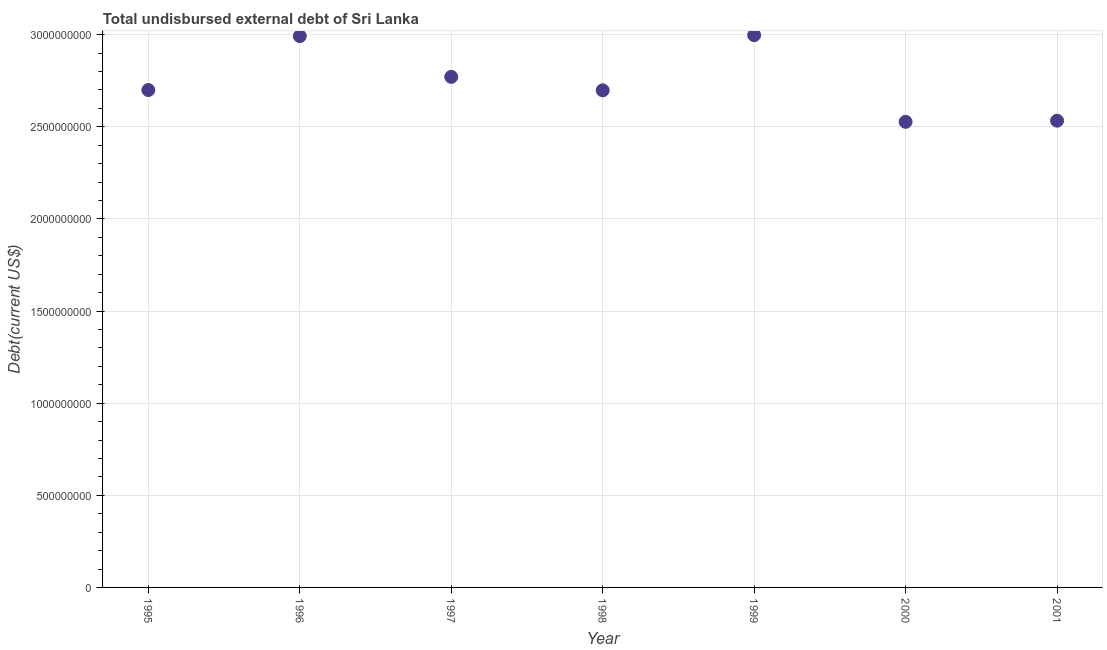What is the total debt in 1995?
Provide a succinct answer. 2.70e+09. Across all years, what is the maximum total debt?
Offer a very short reply. 3.00e+09. Across all years, what is the minimum total debt?
Keep it short and to the point. 2.53e+09. In which year was the total debt maximum?
Your answer should be very brief. 1999. In which year was the total debt minimum?
Provide a succinct answer. 2000. What is the sum of the total debt?
Ensure brevity in your answer.  1.92e+1. What is the difference between the total debt in 1995 and 1997?
Your response must be concise. -7.15e+07. What is the average total debt per year?
Provide a succinct answer. 2.75e+09. What is the median total debt?
Offer a terse response. 2.70e+09. In how many years, is the total debt greater than 2000000000 US$?
Offer a terse response. 7. Do a majority of the years between 1996 and 2001 (inclusive) have total debt greater than 1200000000 US$?
Provide a succinct answer. Yes. What is the ratio of the total debt in 1995 to that in 1996?
Your response must be concise. 0.9. Is the difference between the total debt in 1997 and 1999 greater than the difference between any two years?
Give a very brief answer. No. What is the difference between the highest and the second highest total debt?
Ensure brevity in your answer.  5.28e+06. Is the sum of the total debt in 1995 and 2001 greater than the maximum total debt across all years?
Your response must be concise. Yes. What is the difference between the highest and the lowest total debt?
Offer a very short reply. 4.70e+08. In how many years, is the total debt greater than the average total debt taken over all years?
Give a very brief answer. 3. What is the difference between two consecutive major ticks on the Y-axis?
Your response must be concise. 5.00e+08. Does the graph contain grids?
Provide a short and direct response. Yes. What is the title of the graph?
Offer a terse response. Total undisbursed external debt of Sri Lanka. What is the label or title of the Y-axis?
Give a very brief answer. Debt(current US$). What is the Debt(current US$) in 1995?
Provide a succinct answer. 2.70e+09. What is the Debt(current US$) in 1996?
Give a very brief answer. 2.99e+09. What is the Debt(current US$) in 1997?
Provide a short and direct response. 2.77e+09. What is the Debt(current US$) in 1998?
Your answer should be compact. 2.70e+09. What is the Debt(current US$) in 1999?
Your answer should be very brief. 3.00e+09. What is the Debt(current US$) in 2000?
Keep it short and to the point. 2.53e+09. What is the Debt(current US$) in 2001?
Offer a very short reply. 2.53e+09. What is the difference between the Debt(current US$) in 1995 and 1996?
Make the answer very short. -2.93e+08. What is the difference between the Debt(current US$) in 1995 and 1997?
Keep it short and to the point. -7.15e+07. What is the difference between the Debt(current US$) in 1995 and 1998?
Ensure brevity in your answer.  1.53e+06. What is the difference between the Debt(current US$) in 1995 and 1999?
Give a very brief answer. -2.98e+08. What is the difference between the Debt(current US$) in 1995 and 2000?
Keep it short and to the point. 1.72e+08. What is the difference between the Debt(current US$) in 1995 and 2001?
Keep it short and to the point. 1.66e+08. What is the difference between the Debt(current US$) in 1996 and 1997?
Give a very brief answer. 2.21e+08. What is the difference between the Debt(current US$) in 1996 and 1998?
Offer a terse response. 2.94e+08. What is the difference between the Debt(current US$) in 1996 and 1999?
Offer a very short reply. -5.28e+06. What is the difference between the Debt(current US$) in 1996 and 2000?
Your answer should be compact. 4.65e+08. What is the difference between the Debt(current US$) in 1996 and 2001?
Your answer should be very brief. 4.59e+08. What is the difference between the Debt(current US$) in 1997 and 1998?
Provide a short and direct response. 7.30e+07. What is the difference between the Debt(current US$) in 1997 and 1999?
Provide a succinct answer. -2.26e+08. What is the difference between the Debt(current US$) in 1997 and 2000?
Your response must be concise. 2.44e+08. What is the difference between the Debt(current US$) in 1997 and 2001?
Your answer should be very brief. 2.38e+08. What is the difference between the Debt(current US$) in 1998 and 1999?
Your answer should be compact. -2.99e+08. What is the difference between the Debt(current US$) in 1998 and 2000?
Your response must be concise. 1.71e+08. What is the difference between the Debt(current US$) in 1998 and 2001?
Provide a short and direct response. 1.65e+08. What is the difference between the Debt(current US$) in 1999 and 2000?
Give a very brief answer. 4.70e+08. What is the difference between the Debt(current US$) in 1999 and 2001?
Your answer should be very brief. 4.64e+08. What is the difference between the Debt(current US$) in 2000 and 2001?
Give a very brief answer. -6.21e+06. What is the ratio of the Debt(current US$) in 1995 to that in 1996?
Your answer should be compact. 0.9. What is the ratio of the Debt(current US$) in 1995 to that in 1997?
Keep it short and to the point. 0.97. What is the ratio of the Debt(current US$) in 1995 to that in 1999?
Ensure brevity in your answer.  0.9. What is the ratio of the Debt(current US$) in 1995 to that in 2000?
Ensure brevity in your answer.  1.07. What is the ratio of the Debt(current US$) in 1995 to that in 2001?
Keep it short and to the point. 1.07. What is the ratio of the Debt(current US$) in 1996 to that in 1997?
Your response must be concise. 1.08. What is the ratio of the Debt(current US$) in 1996 to that in 1998?
Provide a short and direct response. 1.11. What is the ratio of the Debt(current US$) in 1996 to that in 2000?
Ensure brevity in your answer.  1.18. What is the ratio of the Debt(current US$) in 1996 to that in 2001?
Give a very brief answer. 1.18. What is the ratio of the Debt(current US$) in 1997 to that in 1999?
Ensure brevity in your answer.  0.92. What is the ratio of the Debt(current US$) in 1997 to that in 2000?
Give a very brief answer. 1.1. What is the ratio of the Debt(current US$) in 1997 to that in 2001?
Offer a terse response. 1.09. What is the ratio of the Debt(current US$) in 1998 to that in 1999?
Ensure brevity in your answer.  0.9. What is the ratio of the Debt(current US$) in 1998 to that in 2000?
Ensure brevity in your answer.  1.07. What is the ratio of the Debt(current US$) in 1998 to that in 2001?
Provide a short and direct response. 1.06. What is the ratio of the Debt(current US$) in 1999 to that in 2000?
Offer a very short reply. 1.19. What is the ratio of the Debt(current US$) in 1999 to that in 2001?
Your answer should be very brief. 1.18. 